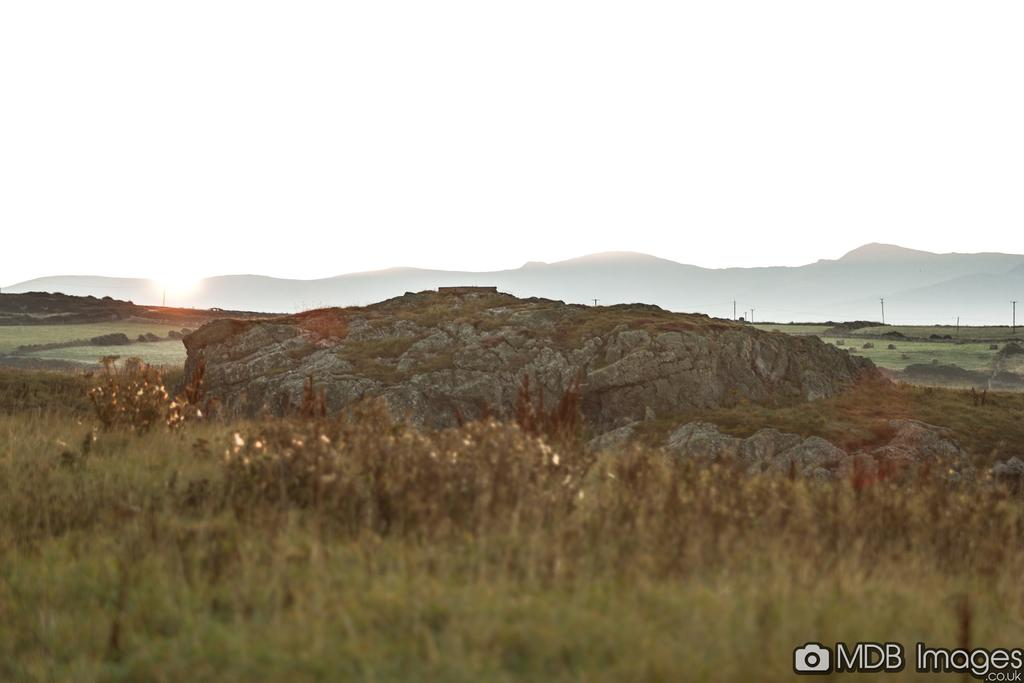What is the main subject in the center of the image? There is a rock in the center of the image. What type of vegetation can be seen at the bottom of the image? There is grass on the surface at the bottom of the image. What can be seen in the background of the image? Current polls, mountains, and the sky are visible in the background of the image. What type of liquid is flowing through the channel in the middle of the image? There is no channel or liquid present in the image. 